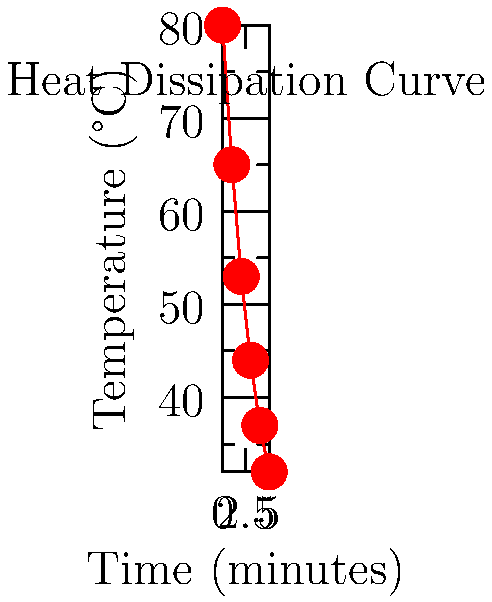In a compact electronic component used for matchmaking algorithms, the temperature drops from 80°C to 32°C over 5 minutes as shown in the graph. Assuming Newton's law of cooling applies, what is the approximate cooling rate constant $k$ (in min$^{-1}$) for this component? To solve this problem, we'll use Newton's law of cooling and the data provided in the graph. The steps are as follows:

1) Newton's law of cooling is given by:
   $T(t) = T_s + (T_0 - T_s)e^{-kt}$
   where $T(t)$ is the temperature at time $t$, $T_s$ is the surrounding temperature, $T_0$ is the initial temperature, and $k$ is the cooling rate constant.

2) We have:
   $T_0 = 80°C$ (initial temperature)
   $T(5) = 32°C$ (final temperature after 5 minutes)
   
3) Assuming room temperature as the surrounding temperature, let $T_s = 25°C$

4) Substituting these values into the equation:
   $32 = 25 + (80 - 25)e^{-5k}$

5) Simplifying:
   $7 = 55e^{-5k}$

6) Taking natural log of both sides:
   $\ln(7/55) = -5k$

7) Solving for $k$:
   $k = -\frac{1}{5}\ln(7/55) \approx 0.41$ min$^{-1}$
Answer: $0.41$ min$^{-1}$ 